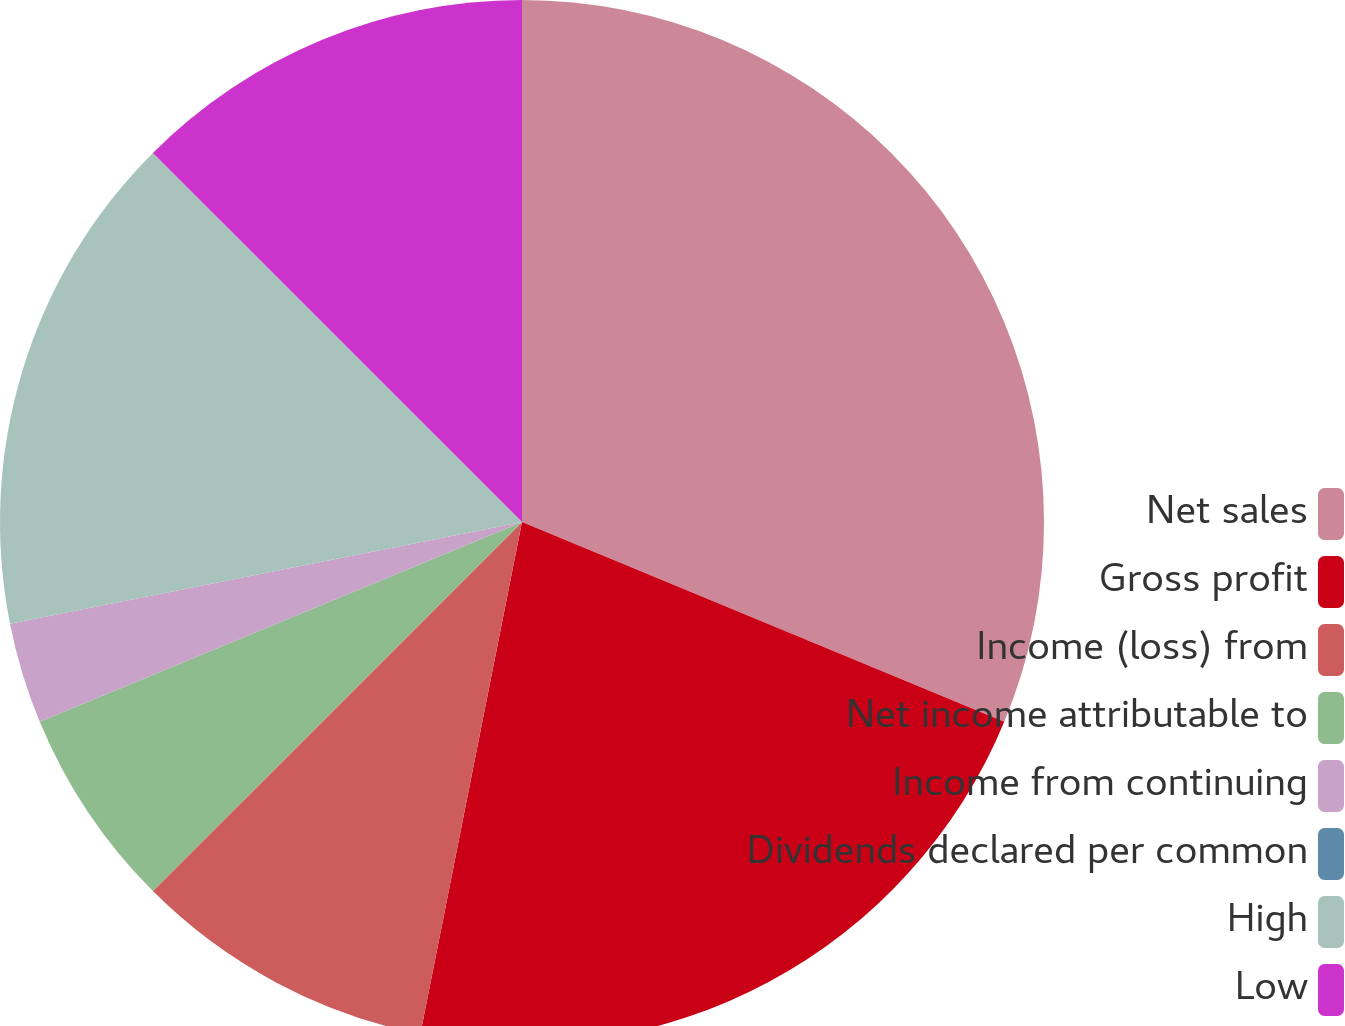Convert chart. <chart><loc_0><loc_0><loc_500><loc_500><pie_chart><fcel>Net sales<fcel>Gross profit<fcel>Income (loss) from<fcel>Net income attributable to<fcel>Income from continuing<fcel>Dividends declared per common<fcel>High<fcel>Low<nl><fcel>31.25%<fcel>21.87%<fcel>9.38%<fcel>6.25%<fcel>3.13%<fcel>0.0%<fcel>15.62%<fcel>12.5%<nl></chart> 